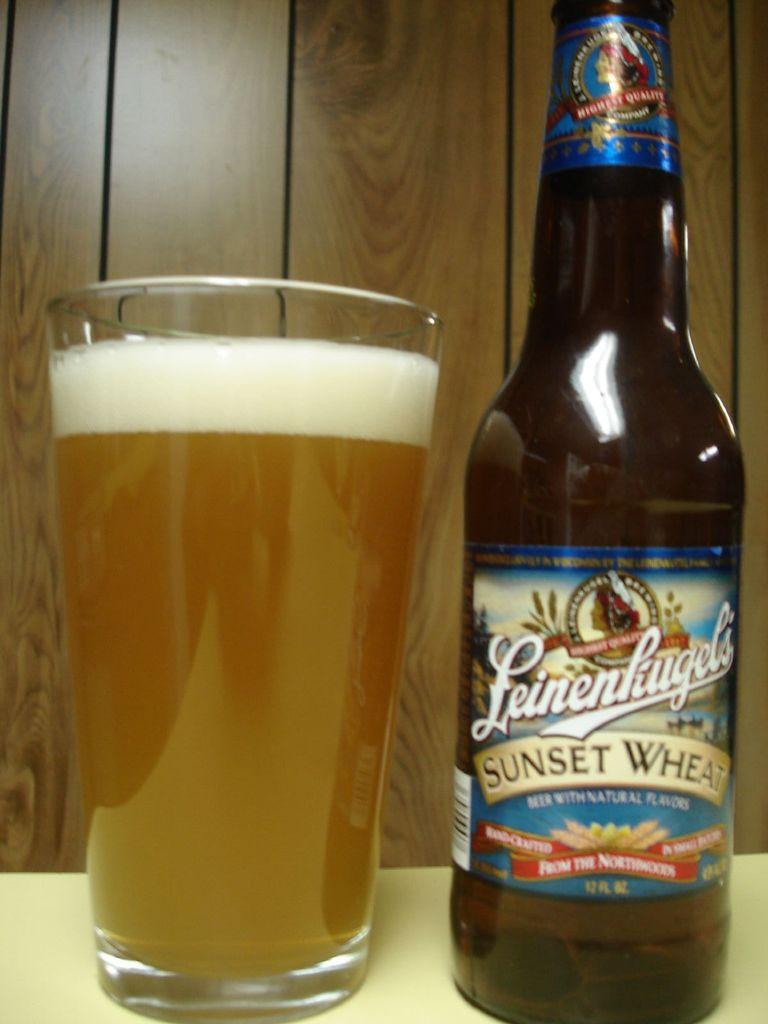Provide a one-sentence caption for the provided image. A glass with Leinenhiugel's sunset wheet beer poured into it. 